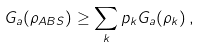Convert formula to latex. <formula><loc_0><loc_0><loc_500><loc_500>G _ { a } ( \rho _ { A B S } ) \geq \sum _ { k } p _ { k } G _ { a } ( \rho _ { k } ) \, ,</formula> 